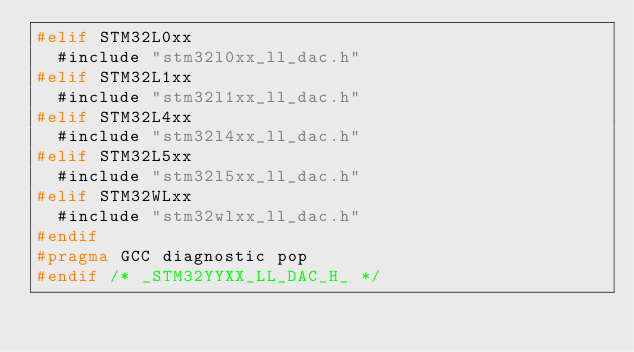Convert code to text. <code><loc_0><loc_0><loc_500><loc_500><_C_>#elif STM32L0xx
  #include "stm32l0xx_ll_dac.h"
#elif STM32L1xx
  #include "stm32l1xx_ll_dac.h"
#elif STM32L4xx
  #include "stm32l4xx_ll_dac.h"
#elif STM32L5xx
  #include "stm32l5xx_ll_dac.h"
#elif STM32WLxx
  #include "stm32wlxx_ll_dac.h"
#endif
#pragma GCC diagnostic pop
#endif /* _STM32YYXX_LL_DAC_H_ */
</code> 